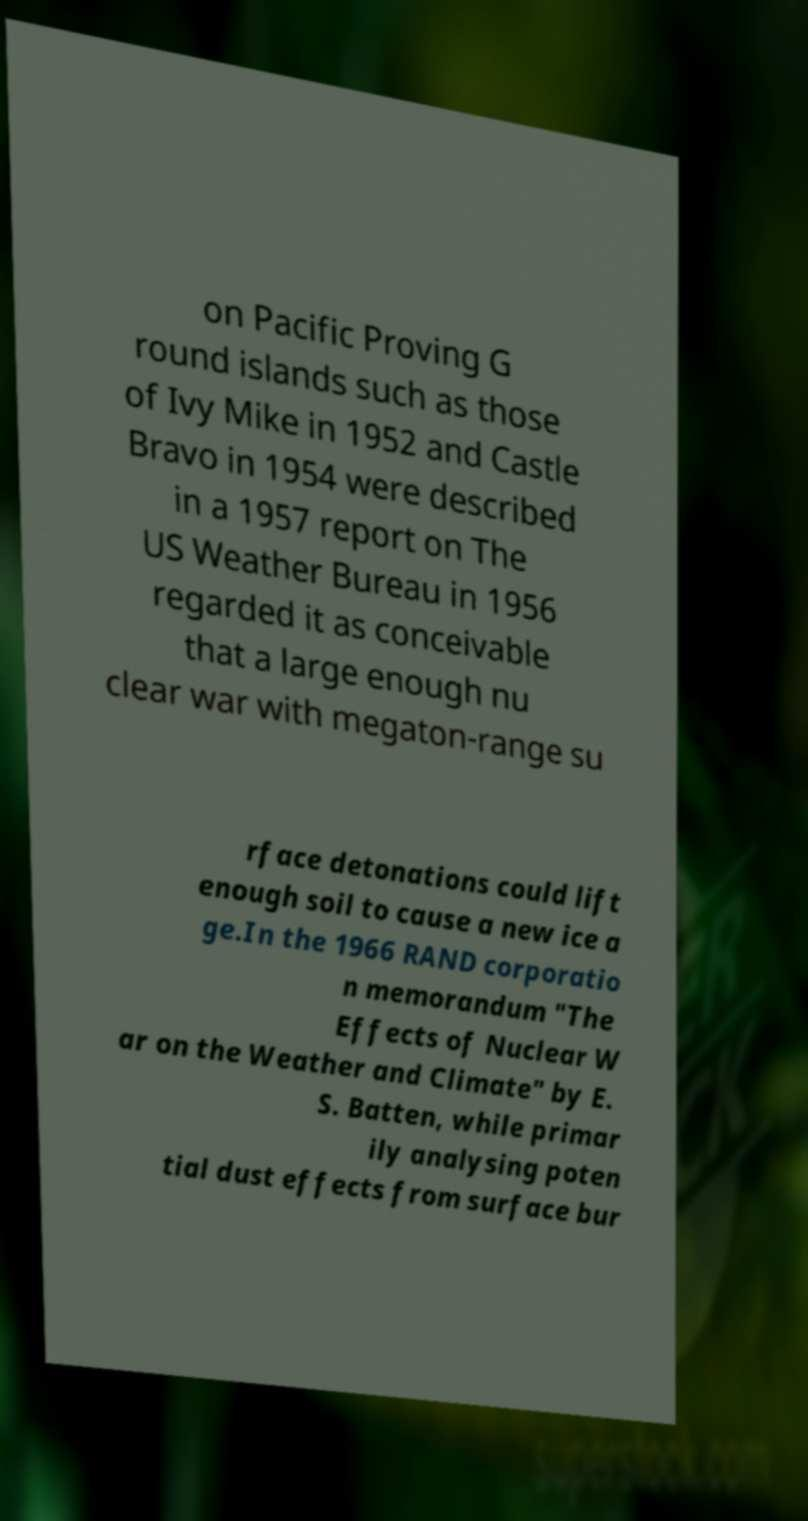I need the written content from this picture converted into text. Can you do that? on Pacific Proving G round islands such as those of Ivy Mike in 1952 and Castle Bravo in 1954 were described in a 1957 report on The US Weather Bureau in 1956 regarded it as conceivable that a large enough nu clear war with megaton-range su rface detonations could lift enough soil to cause a new ice a ge.In the 1966 RAND corporatio n memorandum "The Effects of Nuclear W ar on the Weather and Climate" by E. S. Batten, while primar ily analysing poten tial dust effects from surface bur 